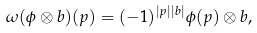Convert formula to latex. <formula><loc_0><loc_0><loc_500><loc_500>\omega ( \phi \otimes b ) ( p ) = ( - 1 ) ^ { | p | | b | } \phi ( p ) \otimes b ,</formula> 